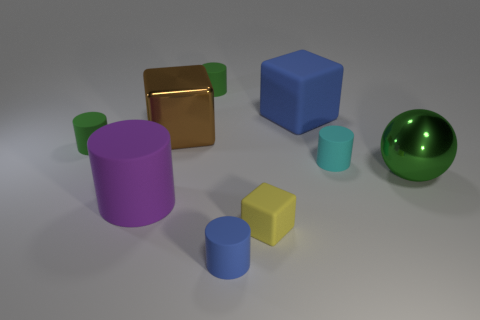There is a blue cube that is the same material as the small cyan cylinder; what is its size?
Offer a terse response. Large. There is a rubber cylinder that is the same color as the big matte cube; what is its size?
Offer a very short reply. Small. There is a blue matte thing behind the big block that is to the left of the blue rubber object to the left of the tiny cube; what is its shape?
Provide a short and direct response. Cube. What number of other things are the same shape as the purple object?
Provide a short and direct response. 4. What is the block that is behind the large shiny object that is on the left side of the small blue matte cylinder made of?
Your answer should be very brief. Rubber. Is the cyan cylinder made of the same material as the green object that is right of the small yellow rubber block?
Give a very brief answer. No. There is a large object that is in front of the big blue matte block and right of the yellow object; what material is it?
Make the answer very short. Metal. The cylinder on the right side of the blue matte object in front of the large green ball is what color?
Provide a short and direct response. Cyan. What material is the small green cylinder right of the purple thing?
Offer a terse response. Rubber. Is the number of small cylinders less than the number of small blue objects?
Your response must be concise. No. 